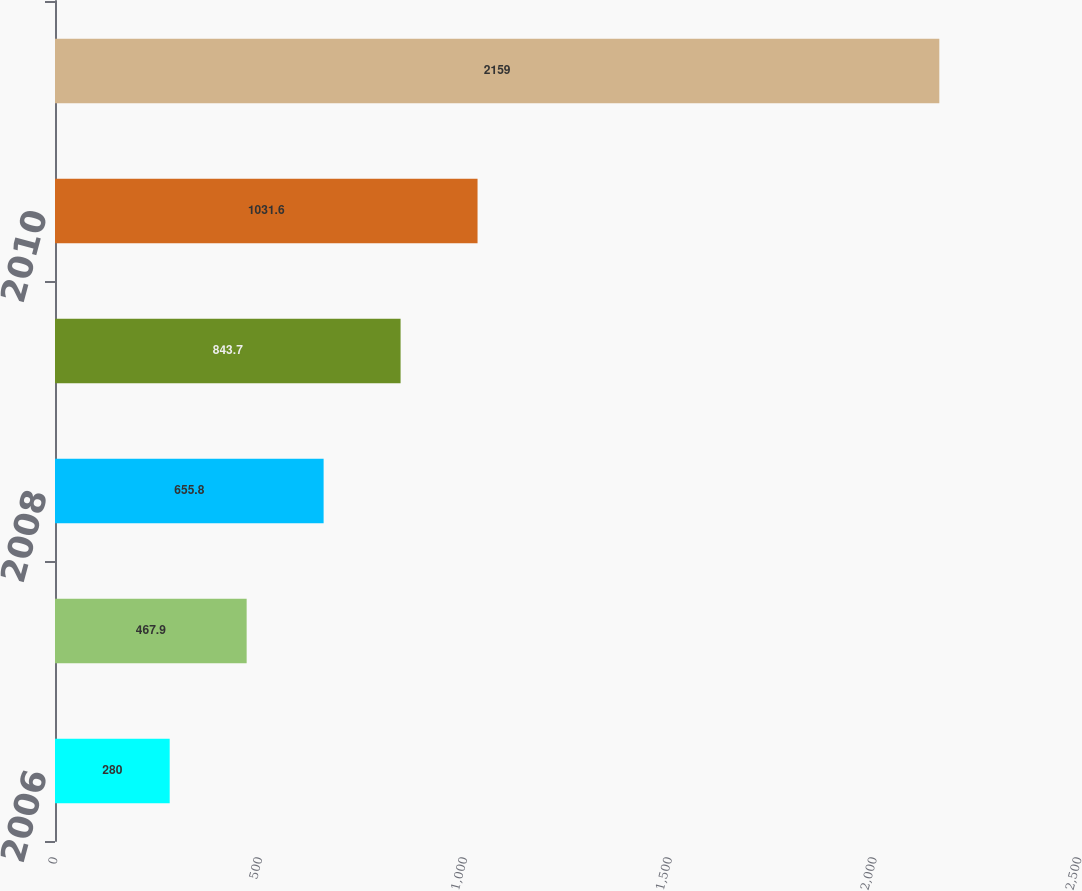Convert chart. <chart><loc_0><loc_0><loc_500><loc_500><bar_chart><fcel>2006<fcel>2007<fcel>2008<fcel>2009<fcel>2010<fcel>Years 2011 - 2015<nl><fcel>280<fcel>467.9<fcel>655.8<fcel>843.7<fcel>1031.6<fcel>2159<nl></chart> 